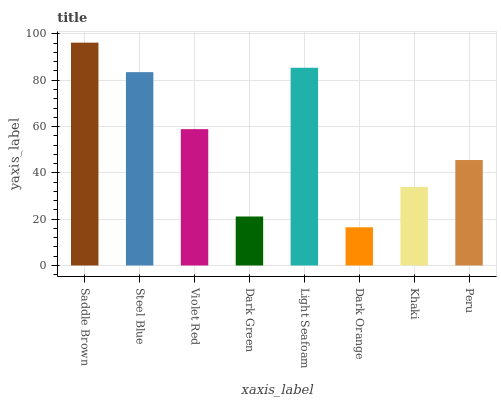Is Dark Orange the minimum?
Answer yes or no. Yes. Is Saddle Brown the maximum?
Answer yes or no. Yes. Is Steel Blue the minimum?
Answer yes or no. No. Is Steel Blue the maximum?
Answer yes or no. No. Is Saddle Brown greater than Steel Blue?
Answer yes or no. Yes. Is Steel Blue less than Saddle Brown?
Answer yes or no. Yes. Is Steel Blue greater than Saddle Brown?
Answer yes or no. No. Is Saddle Brown less than Steel Blue?
Answer yes or no. No. Is Violet Red the high median?
Answer yes or no. Yes. Is Peru the low median?
Answer yes or no. Yes. Is Khaki the high median?
Answer yes or no. No. Is Light Seafoam the low median?
Answer yes or no. No. 